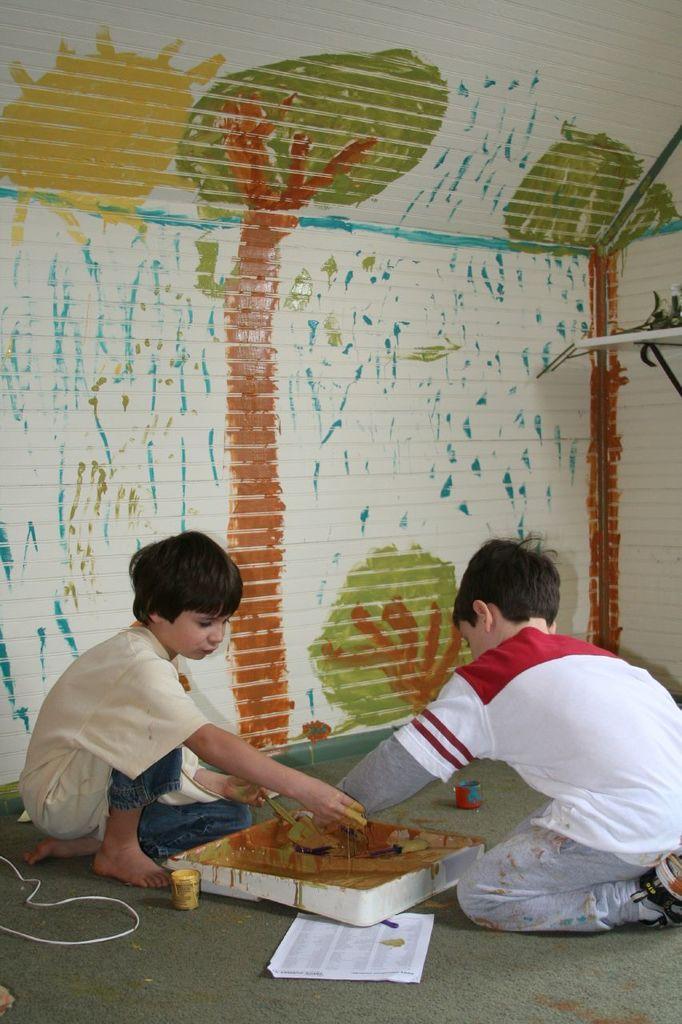Can you describe this image briefly? This image consists of two children playing with the paints. At the bottom, there is a floor. In the background, there is a wall on which there are paintings. 